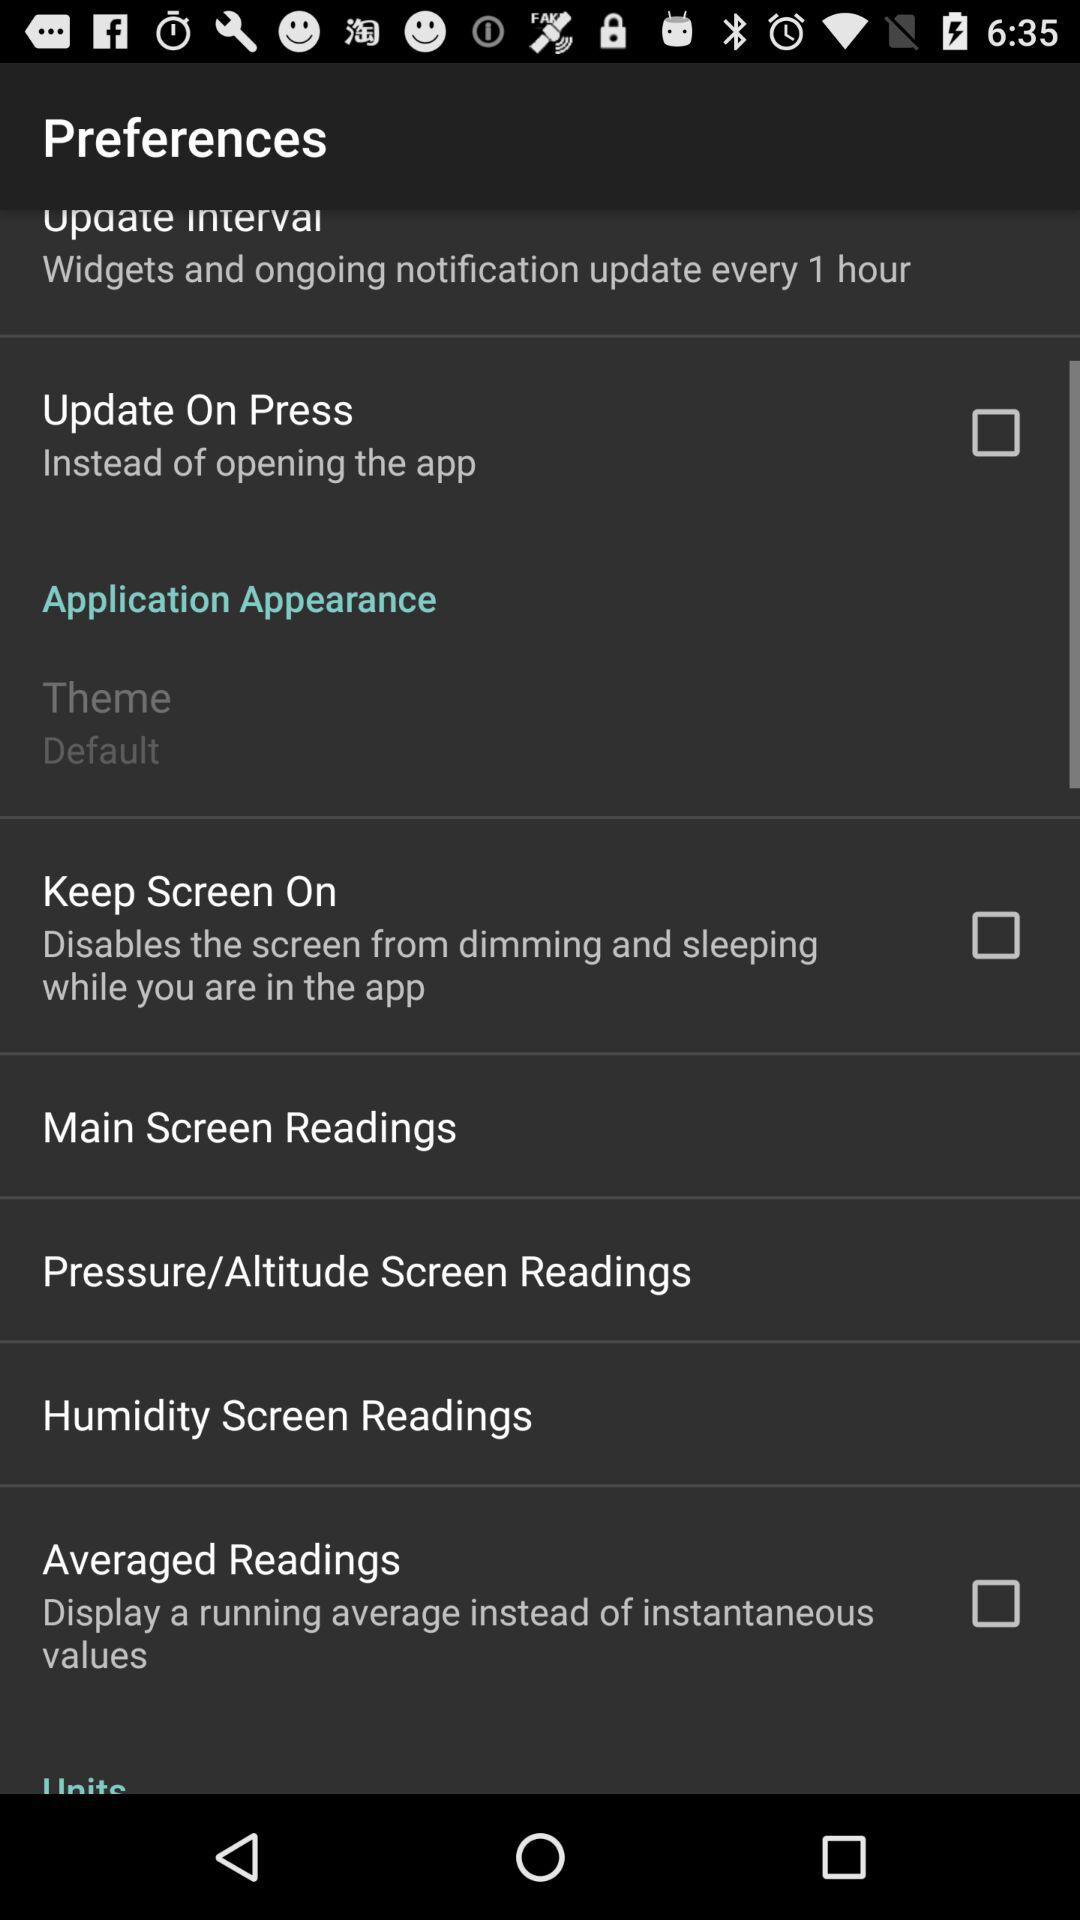What to display instead of instantaneous values? Instead of instantaneous values, display a running average. 